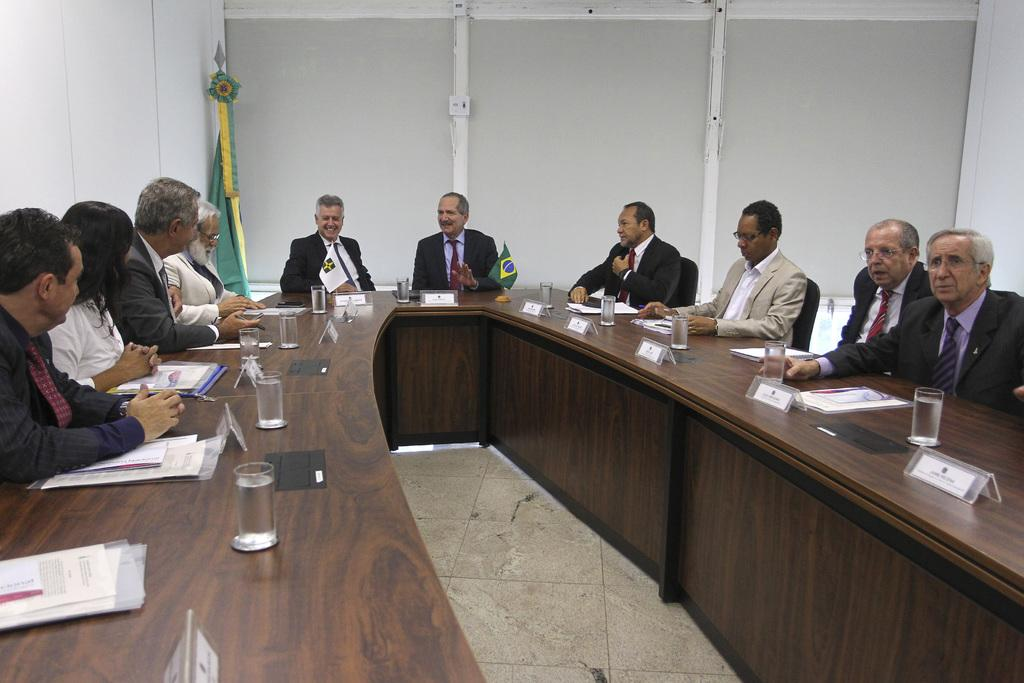What are the persons in the image doing? The persons in the image are sitting on chairs. What objects are on the table in the image? There are glasses, papers, and other things on the table. Can you describe the flag visible in the image? The flag is visible in the distance. What type of police car can be seen in the image? There is no police car present in the image. How far away is the cat from the persons sitting on chairs? There is no cat present in the image. 